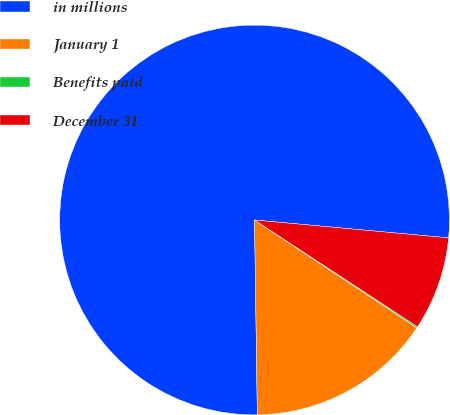Convert chart to OTSL. <chart><loc_0><loc_0><loc_500><loc_500><pie_chart><fcel>in millions<fcel>January 1<fcel>Benefits paid<fcel>December 31<nl><fcel>76.69%<fcel>15.43%<fcel>0.11%<fcel>7.77%<nl></chart> 